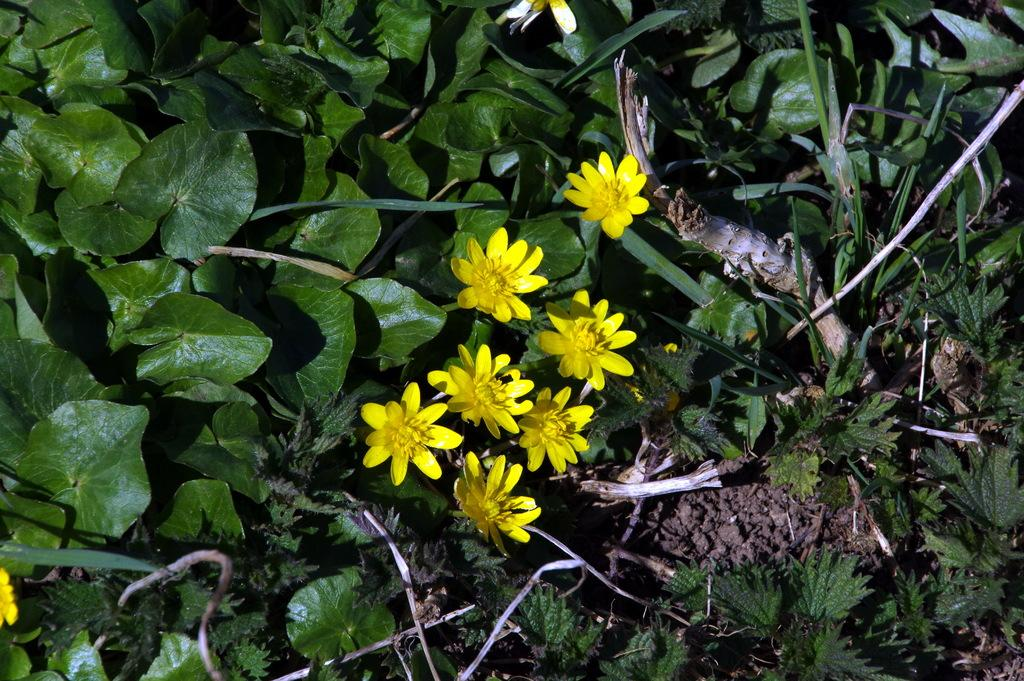What type of living organisms can be seen in the image? Plants can be seen in the image. What color are the flowers on the plants in the image? The flowers on the plants in the image are yellow. What type of mailbox is present in the image? There is no mailbox present in the image; it only features plants with yellow flowers. 